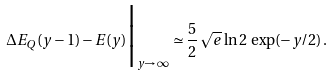Convert formula to latex. <formula><loc_0><loc_0><loc_500><loc_500>\Delta E _ { Q } ( y - 1 ) - E ( y ) \Big | _ { y \rightarrow \, \infty } \simeq \frac { 5 } { 2 } \, \sqrt { e } \, \ln 2 \, \exp ( - y / 2 ) \, .</formula> 